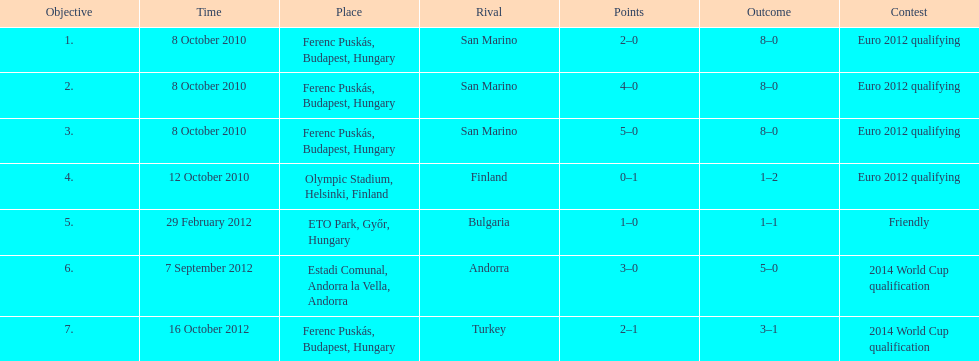What is the total number of international goals ádám szalai has made? 7. Can you give me this table as a dict? {'header': ['Objective', 'Time', 'Place', 'Rival', 'Points', 'Outcome', 'Contest'], 'rows': [['1.', '8 October 2010', 'Ferenc Puskás, Budapest, Hungary', 'San Marino', '2–0', '8–0', 'Euro 2012 qualifying'], ['2.', '8 October 2010', 'Ferenc Puskás, Budapest, Hungary', 'San Marino', '4–0', '8–0', 'Euro 2012 qualifying'], ['3.', '8 October 2010', 'Ferenc Puskás, Budapest, Hungary', 'San Marino', '5–0', '8–0', 'Euro 2012 qualifying'], ['4.', '12 October 2010', 'Olympic Stadium, Helsinki, Finland', 'Finland', '0–1', '1–2', 'Euro 2012 qualifying'], ['5.', '29 February 2012', 'ETO Park, Győr, Hungary', 'Bulgaria', '1–0', '1–1', 'Friendly'], ['6.', '7 September 2012', 'Estadi Comunal, Andorra la Vella, Andorra', 'Andorra', '3–0', '5–0', '2014 World Cup qualification'], ['7.', '16 October 2012', 'Ferenc Puskás, Budapest, Hungary', 'Turkey', '2–1', '3–1', '2014 World Cup qualification']]} 